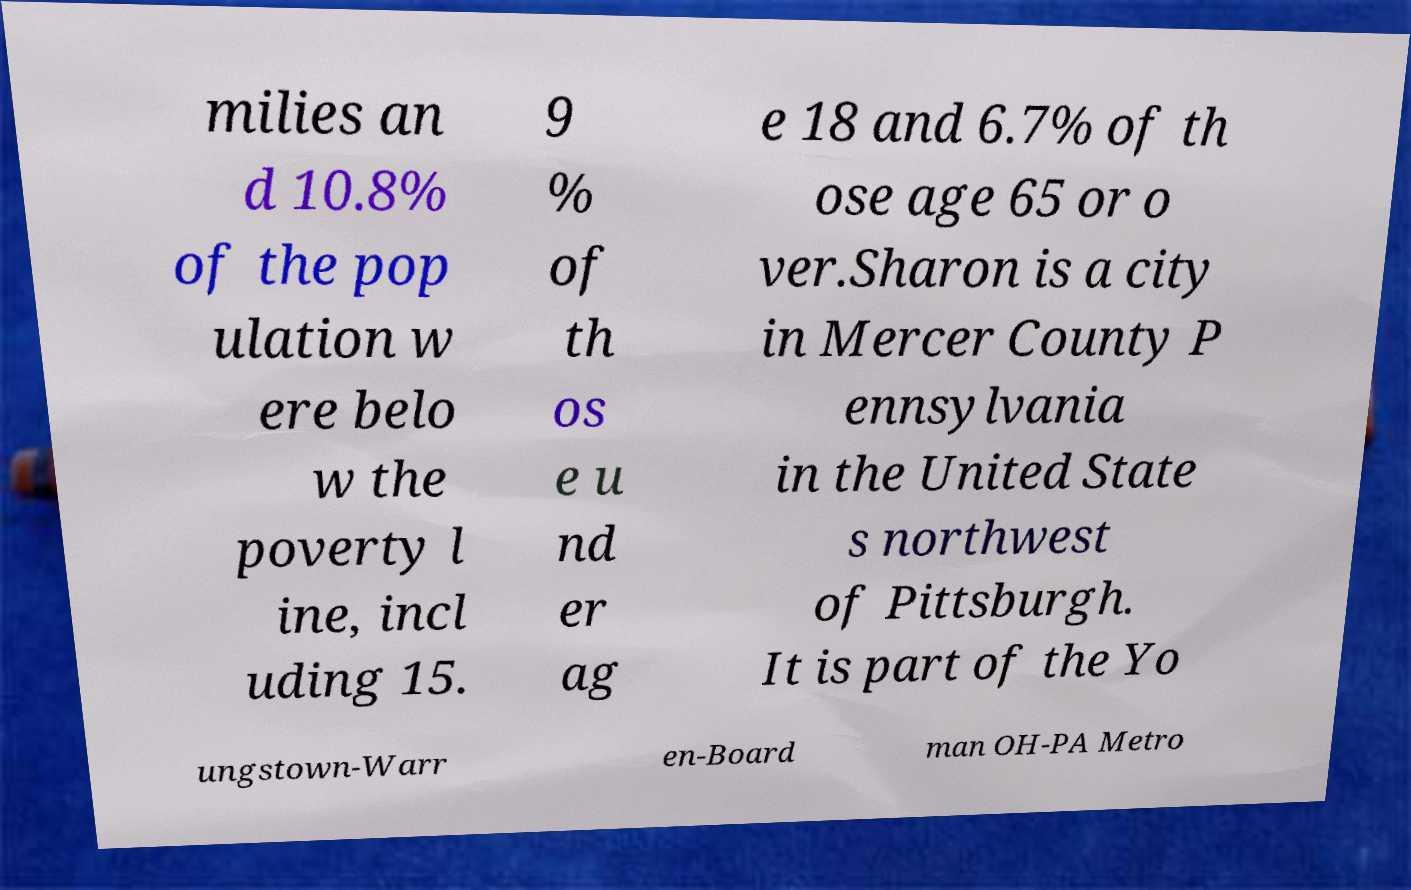Could you assist in decoding the text presented in this image and type it out clearly? milies an d 10.8% of the pop ulation w ere belo w the poverty l ine, incl uding 15. 9 % of th os e u nd er ag e 18 and 6.7% of th ose age 65 or o ver.Sharon is a city in Mercer County P ennsylvania in the United State s northwest of Pittsburgh. It is part of the Yo ungstown-Warr en-Board man OH-PA Metro 